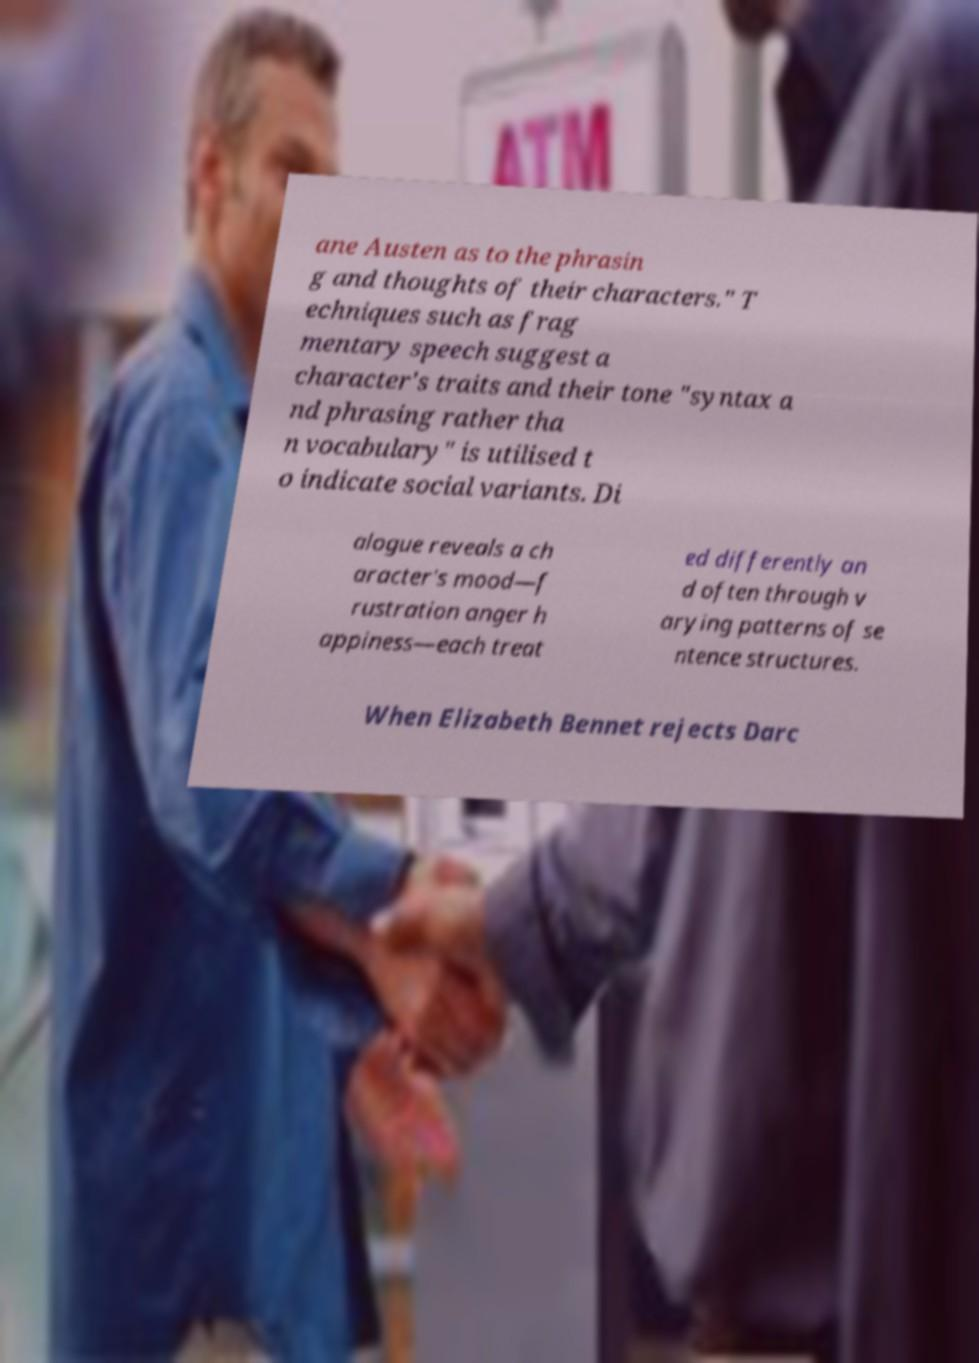Please read and relay the text visible in this image. What does it say? ane Austen as to the phrasin g and thoughts of their characters." T echniques such as frag mentary speech suggest a character's traits and their tone "syntax a nd phrasing rather tha n vocabulary" is utilised t o indicate social variants. Di alogue reveals a ch aracter's mood—f rustration anger h appiness—each treat ed differently an d often through v arying patterns of se ntence structures. When Elizabeth Bennet rejects Darc 